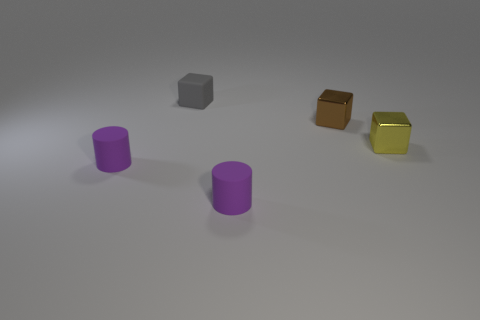Subtract all small yellow shiny blocks. How many blocks are left? 2 Subtract 2 cubes. How many cubes are left? 1 Add 3 yellow metallic blocks. How many objects exist? 8 Subtract all gray cubes. How many cubes are left? 2 Subtract 0 gray spheres. How many objects are left? 5 Subtract all blocks. How many objects are left? 2 Subtract all gray cubes. Subtract all purple cylinders. How many cubes are left? 2 Subtract all small rubber cubes. Subtract all small cylinders. How many objects are left? 2 Add 3 small yellow objects. How many small yellow objects are left? 4 Add 3 small matte things. How many small matte things exist? 6 